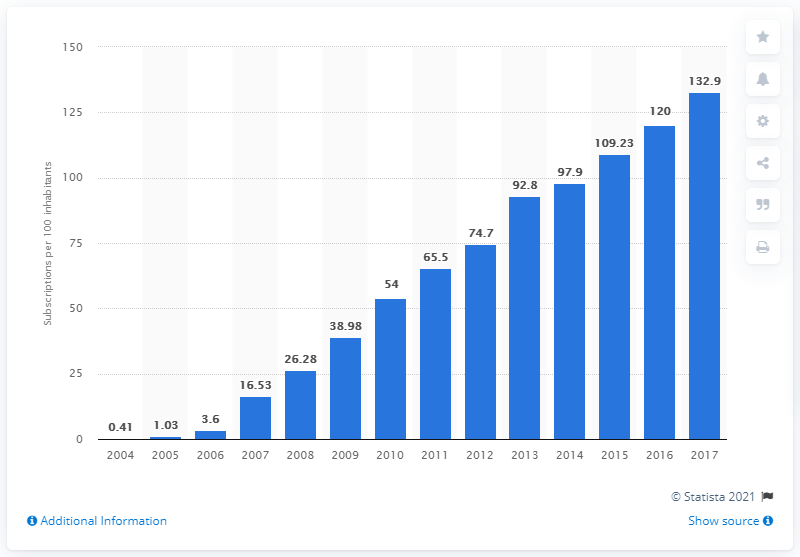Outline some significant characteristics in this image. There were an estimated 132.9 mobile broadband subscriptions per 100 inhabitants in the United States between 2004 and 2017. 